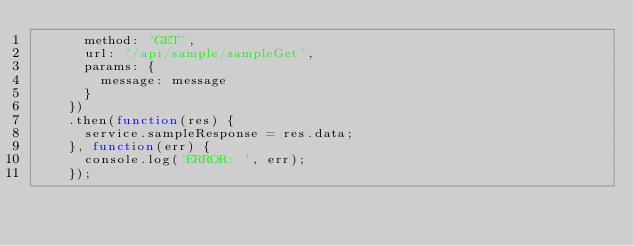Convert code to text. <code><loc_0><loc_0><loc_500><loc_500><_JavaScript_>      method: 'GET',
      url: '/api/sample/sampleGet',
      params: {
        message: message
      }
    })
    .then(function(res) {
      service.sampleResponse = res.data;
    }, function(err) {
      console.log('ERROR: ', err);
    });</code> 